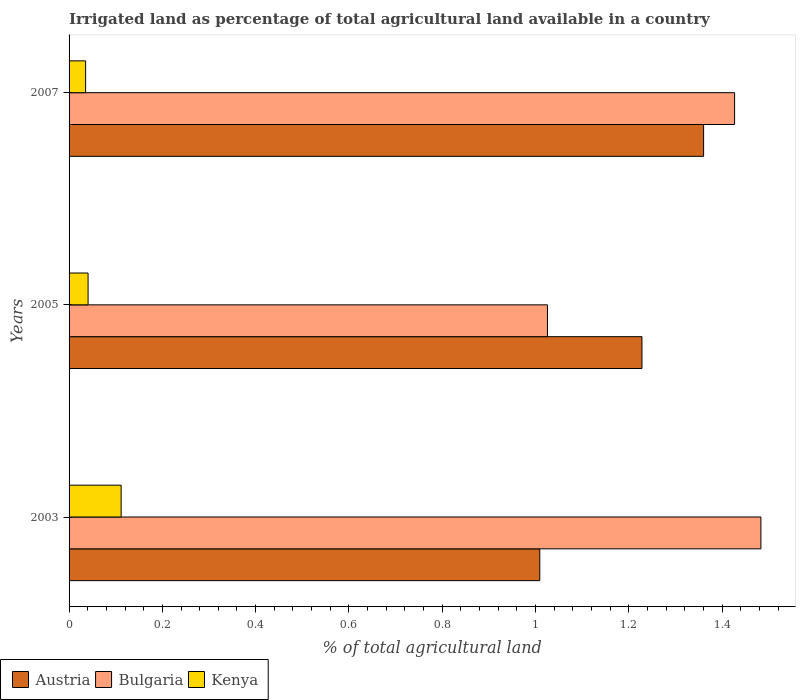How many different coloured bars are there?
Provide a short and direct response. 3. How many groups of bars are there?
Provide a succinct answer. 3. How many bars are there on the 1st tick from the top?
Provide a short and direct response. 3. What is the percentage of irrigated land in Kenya in 2007?
Offer a very short reply. 0.04. Across all years, what is the maximum percentage of irrigated land in Austria?
Offer a terse response. 1.36. Across all years, what is the minimum percentage of irrigated land in Bulgaria?
Make the answer very short. 1.03. In which year was the percentage of irrigated land in Bulgaria minimum?
Keep it short and to the point. 2005. What is the total percentage of irrigated land in Kenya in the graph?
Offer a terse response. 0.19. What is the difference between the percentage of irrigated land in Bulgaria in 2003 and that in 2005?
Provide a succinct answer. 0.46. What is the difference between the percentage of irrigated land in Kenya in 2007 and the percentage of irrigated land in Bulgaria in 2003?
Your answer should be compact. -1.45. What is the average percentage of irrigated land in Austria per year?
Your answer should be compact. 1.2. In the year 2007, what is the difference between the percentage of irrigated land in Austria and percentage of irrigated land in Bulgaria?
Offer a very short reply. -0.07. In how many years, is the percentage of irrigated land in Kenya greater than 0.28 %?
Your response must be concise. 0. What is the ratio of the percentage of irrigated land in Kenya in 2005 to that in 2007?
Your response must be concise. 1.15. Is the percentage of irrigated land in Austria in 2003 less than that in 2005?
Provide a succinct answer. Yes. What is the difference between the highest and the second highest percentage of irrigated land in Bulgaria?
Offer a very short reply. 0.06. What is the difference between the highest and the lowest percentage of irrigated land in Kenya?
Offer a very short reply. 0.08. In how many years, is the percentage of irrigated land in Bulgaria greater than the average percentage of irrigated land in Bulgaria taken over all years?
Provide a short and direct response. 2. How many bars are there?
Offer a terse response. 9. Are all the bars in the graph horizontal?
Your answer should be very brief. Yes. How many years are there in the graph?
Your answer should be compact. 3. Where does the legend appear in the graph?
Provide a short and direct response. Bottom left. How many legend labels are there?
Provide a succinct answer. 3. How are the legend labels stacked?
Offer a terse response. Horizontal. What is the title of the graph?
Keep it short and to the point. Irrigated land as percentage of total agricultural land available in a country. Does "Uzbekistan" appear as one of the legend labels in the graph?
Offer a terse response. No. What is the label or title of the X-axis?
Provide a short and direct response. % of total agricultural land. What is the label or title of the Y-axis?
Make the answer very short. Years. What is the % of total agricultural land in Austria in 2003?
Make the answer very short. 1.01. What is the % of total agricultural land in Bulgaria in 2003?
Keep it short and to the point. 1.48. What is the % of total agricultural land in Kenya in 2003?
Your answer should be compact. 0.11. What is the % of total agricultural land in Austria in 2005?
Offer a very short reply. 1.23. What is the % of total agricultural land of Bulgaria in 2005?
Give a very brief answer. 1.03. What is the % of total agricultural land of Kenya in 2005?
Make the answer very short. 0.04. What is the % of total agricultural land in Austria in 2007?
Ensure brevity in your answer.  1.36. What is the % of total agricultural land in Bulgaria in 2007?
Offer a terse response. 1.43. What is the % of total agricultural land in Kenya in 2007?
Make the answer very short. 0.04. Across all years, what is the maximum % of total agricultural land of Austria?
Offer a terse response. 1.36. Across all years, what is the maximum % of total agricultural land in Bulgaria?
Your response must be concise. 1.48. Across all years, what is the maximum % of total agricultural land of Kenya?
Your answer should be very brief. 0.11. Across all years, what is the minimum % of total agricultural land in Austria?
Ensure brevity in your answer.  1.01. Across all years, what is the minimum % of total agricultural land of Bulgaria?
Offer a terse response. 1.03. Across all years, what is the minimum % of total agricultural land in Kenya?
Ensure brevity in your answer.  0.04. What is the total % of total agricultural land in Austria in the graph?
Provide a short and direct response. 3.6. What is the total % of total agricultural land in Bulgaria in the graph?
Your answer should be very brief. 3.94. What is the total % of total agricultural land in Kenya in the graph?
Your answer should be very brief. 0.19. What is the difference between the % of total agricultural land of Austria in 2003 and that in 2005?
Provide a short and direct response. -0.22. What is the difference between the % of total agricultural land in Bulgaria in 2003 and that in 2005?
Keep it short and to the point. 0.46. What is the difference between the % of total agricultural land in Kenya in 2003 and that in 2005?
Provide a short and direct response. 0.07. What is the difference between the % of total agricultural land of Austria in 2003 and that in 2007?
Offer a very short reply. -0.35. What is the difference between the % of total agricultural land in Bulgaria in 2003 and that in 2007?
Your answer should be very brief. 0.06. What is the difference between the % of total agricultural land in Kenya in 2003 and that in 2007?
Your answer should be very brief. 0.08. What is the difference between the % of total agricultural land of Austria in 2005 and that in 2007?
Provide a succinct answer. -0.13. What is the difference between the % of total agricultural land of Bulgaria in 2005 and that in 2007?
Give a very brief answer. -0.4. What is the difference between the % of total agricultural land of Kenya in 2005 and that in 2007?
Your answer should be compact. 0.01. What is the difference between the % of total agricultural land of Austria in 2003 and the % of total agricultural land of Bulgaria in 2005?
Ensure brevity in your answer.  -0.02. What is the difference between the % of total agricultural land in Austria in 2003 and the % of total agricultural land in Kenya in 2005?
Offer a very short reply. 0.97. What is the difference between the % of total agricultural land in Bulgaria in 2003 and the % of total agricultural land in Kenya in 2005?
Ensure brevity in your answer.  1.44. What is the difference between the % of total agricultural land in Austria in 2003 and the % of total agricultural land in Bulgaria in 2007?
Your answer should be compact. -0.42. What is the difference between the % of total agricultural land in Austria in 2003 and the % of total agricultural land in Kenya in 2007?
Offer a terse response. 0.97. What is the difference between the % of total agricultural land of Bulgaria in 2003 and the % of total agricultural land of Kenya in 2007?
Ensure brevity in your answer.  1.45. What is the difference between the % of total agricultural land of Austria in 2005 and the % of total agricultural land of Bulgaria in 2007?
Your answer should be very brief. -0.2. What is the difference between the % of total agricultural land in Austria in 2005 and the % of total agricultural land in Kenya in 2007?
Offer a very short reply. 1.19. What is the difference between the % of total agricultural land of Bulgaria in 2005 and the % of total agricultural land of Kenya in 2007?
Keep it short and to the point. 0.99. What is the average % of total agricultural land of Austria per year?
Give a very brief answer. 1.2. What is the average % of total agricultural land of Bulgaria per year?
Offer a terse response. 1.31. What is the average % of total agricultural land of Kenya per year?
Your response must be concise. 0.06. In the year 2003, what is the difference between the % of total agricultural land in Austria and % of total agricultural land in Bulgaria?
Your answer should be compact. -0.47. In the year 2003, what is the difference between the % of total agricultural land of Austria and % of total agricultural land of Kenya?
Your response must be concise. 0.9. In the year 2003, what is the difference between the % of total agricultural land of Bulgaria and % of total agricultural land of Kenya?
Your answer should be very brief. 1.37. In the year 2005, what is the difference between the % of total agricultural land in Austria and % of total agricultural land in Bulgaria?
Keep it short and to the point. 0.2. In the year 2005, what is the difference between the % of total agricultural land of Austria and % of total agricultural land of Kenya?
Provide a short and direct response. 1.19. In the year 2005, what is the difference between the % of total agricultural land in Bulgaria and % of total agricultural land in Kenya?
Provide a short and direct response. 0.98. In the year 2007, what is the difference between the % of total agricultural land in Austria and % of total agricultural land in Bulgaria?
Make the answer very short. -0.07. In the year 2007, what is the difference between the % of total agricultural land in Austria and % of total agricultural land in Kenya?
Provide a succinct answer. 1.32. In the year 2007, what is the difference between the % of total agricultural land of Bulgaria and % of total agricultural land of Kenya?
Ensure brevity in your answer.  1.39. What is the ratio of the % of total agricultural land of Austria in 2003 to that in 2005?
Offer a terse response. 0.82. What is the ratio of the % of total agricultural land in Bulgaria in 2003 to that in 2005?
Your answer should be very brief. 1.45. What is the ratio of the % of total agricultural land of Kenya in 2003 to that in 2005?
Your response must be concise. 2.74. What is the ratio of the % of total agricultural land of Austria in 2003 to that in 2007?
Ensure brevity in your answer.  0.74. What is the ratio of the % of total agricultural land in Bulgaria in 2003 to that in 2007?
Your answer should be very brief. 1.04. What is the ratio of the % of total agricultural land in Kenya in 2003 to that in 2007?
Make the answer very short. 3.15. What is the ratio of the % of total agricultural land in Austria in 2005 to that in 2007?
Give a very brief answer. 0.9. What is the ratio of the % of total agricultural land in Bulgaria in 2005 to that in 2007?
Ensure brevity in your answer.  0.72. What is the ratio of the % of total agricultural land of Kenya in 2005 to that in 2007?
Your answer should be very brief. 1.15. What is the difference between the highest and the second highest % of total agricultural land of Austria?
Give a very brief answer. 0.13. What is the difference between the highest and the second highest % of total agricultural land in Bulgaria?
Make the answer very short. 0.06. What is the difference between the highest and the second highest % of total agricultural land of Kenya?
Your response must be concise. 0.07. What is the difference between the highest and the lowest % of total agricultural land in Austria?
Make the answer very short. 0.35. What is the difference between the highest and the lowest % of total agricultural land in Bulgaria?
Offer a terse response. 0.46. What is the difference between the highest and the lowest % of total agricultural land of Kenya?
Your answer should be compact. 0.08. 